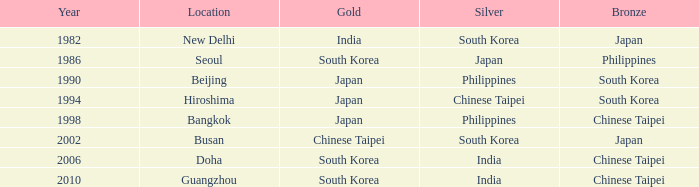Which bronze has a year before 1994, and a silver belonging to south korea? Japan. 